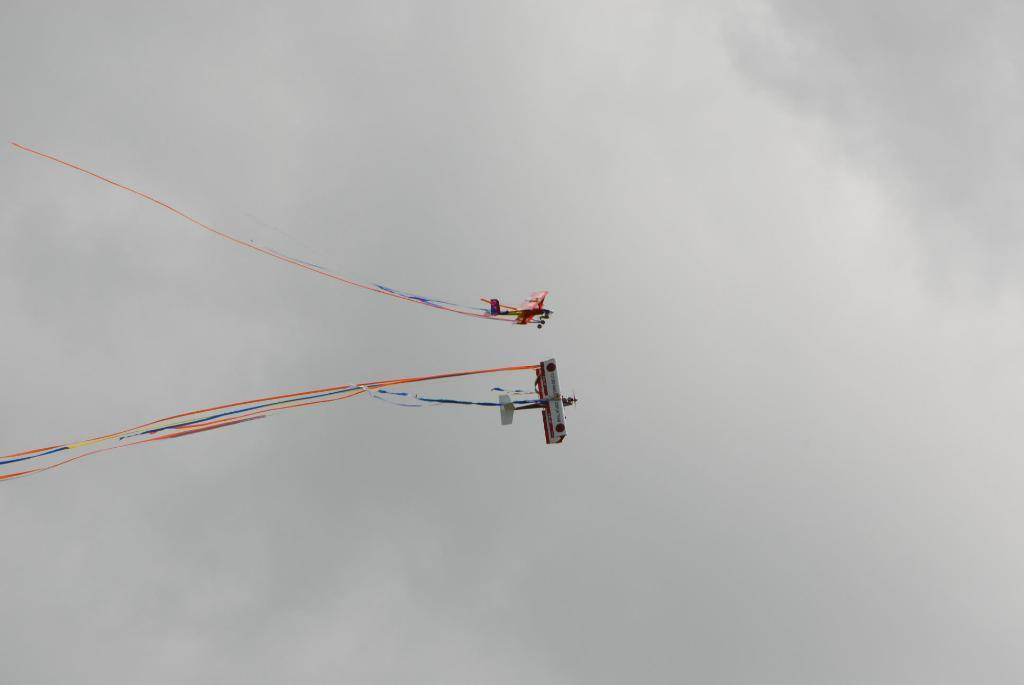What is happening in the sky in the image? There are planes in the air in the image. What else can be seen in the sky besides the planes? There are clouds visible in the image. Can you see a rat on a boat in the image? No, there is no rat or boat present in the image. 